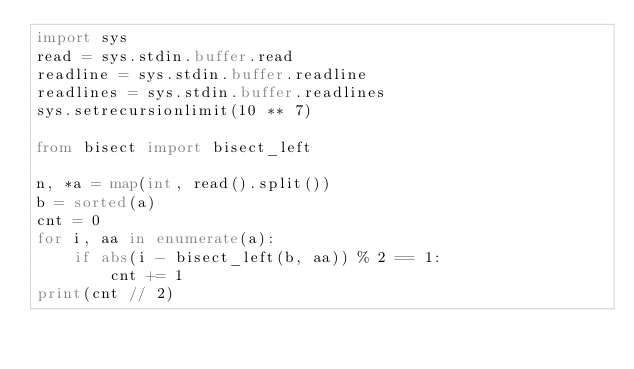Convert code to text. <code><loc_0><loc_0><loc_500><loc_500><_Python_>import sys
read = sys.stdin.buffer.read
readline = sys.stdin.buffer.readline
readlines = sys.stdin.buffer.readlines
sys.setrecursionlimit(10 ** 7)

from bisect import bisect_left

n, *a = map(int, read().split())
b = sorted(a)
cnt = 0
for i, aa in enumerate(a):
    if abs(i - bisect_left(b, aa)) % 2 == 1:
        cnt += 1
print(cnt // 2)
</code> 